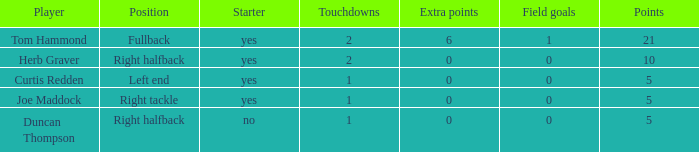Name the fewest touchdowns 1.0. 